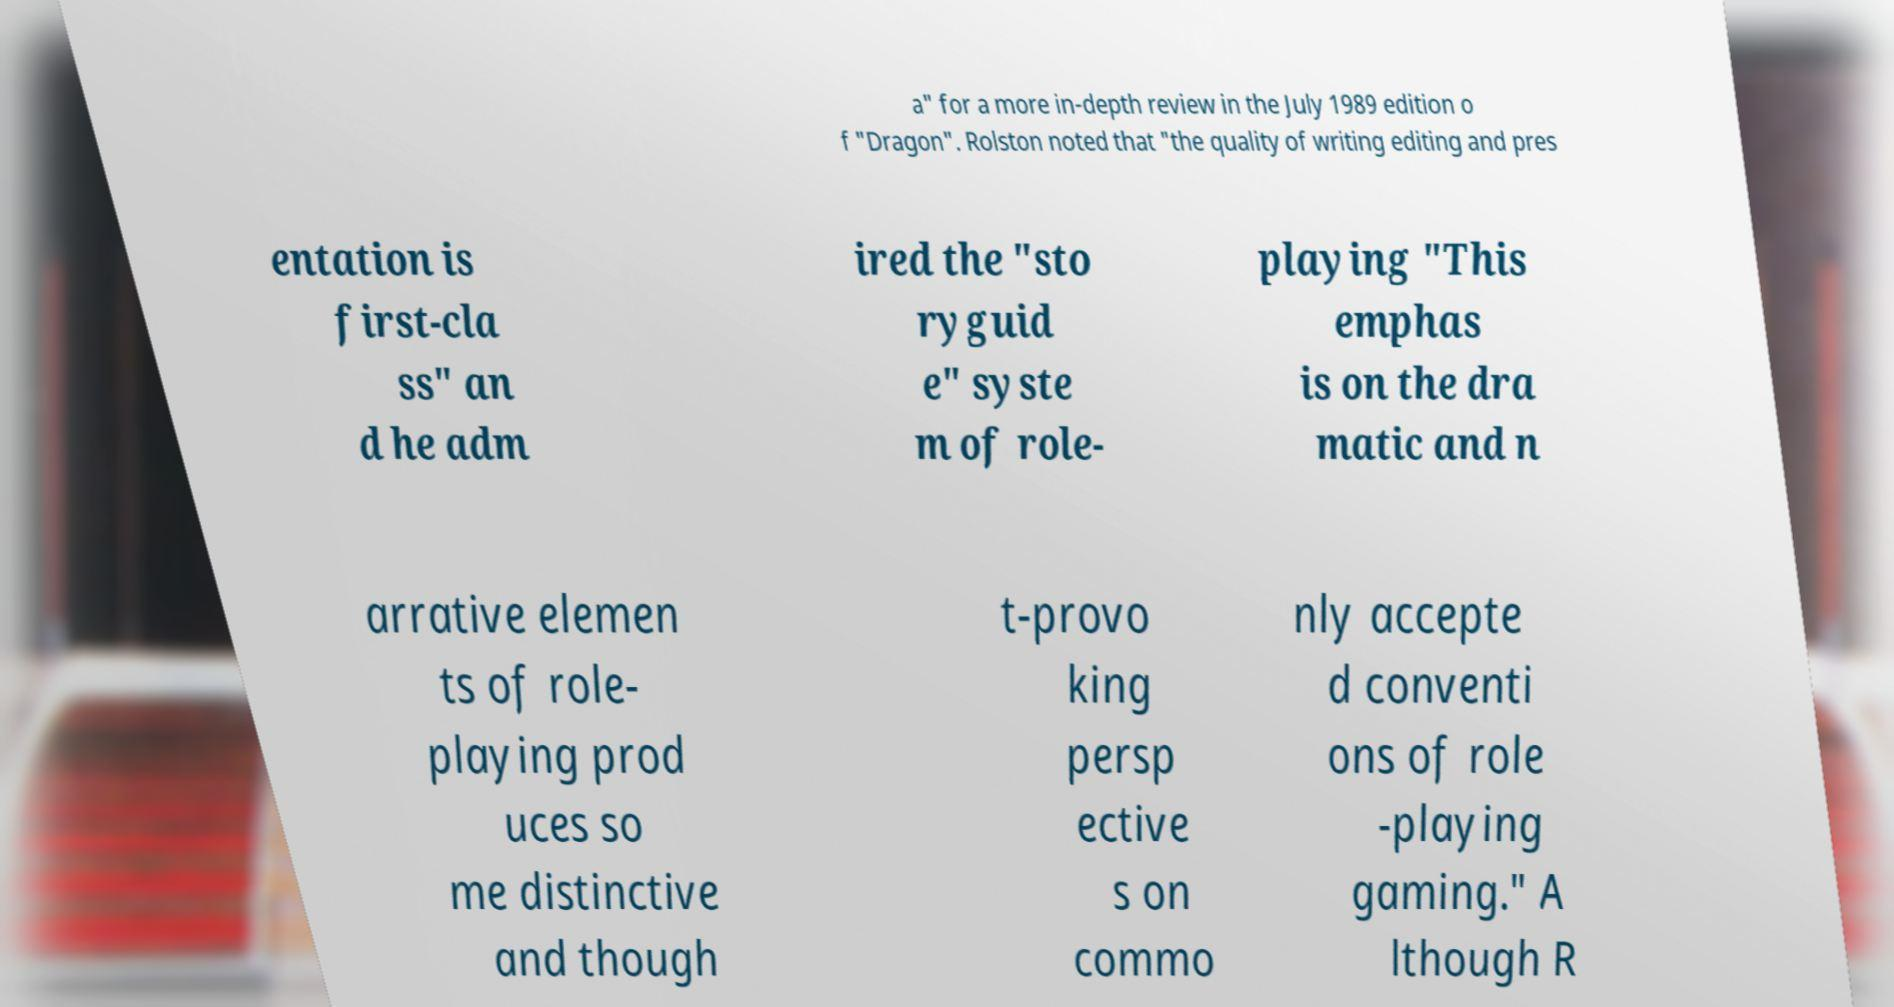Please read and relay the text visible in this image. What does it say? a" for a more in-depth review in the July 1989 edition o f "Dragon". Rolston noted that "the quality of writing editing and pres entation is first-cla ss" an d he adm ired the "sto ryguid e" syste m of role- playing "This emphas is on the dra matic and n arrative elemen ts of role- playing prod uces so me distinctive and though t-provo king persp ective s on commo nly accepte d conventi ons of role -playing gaming." A lthough R 